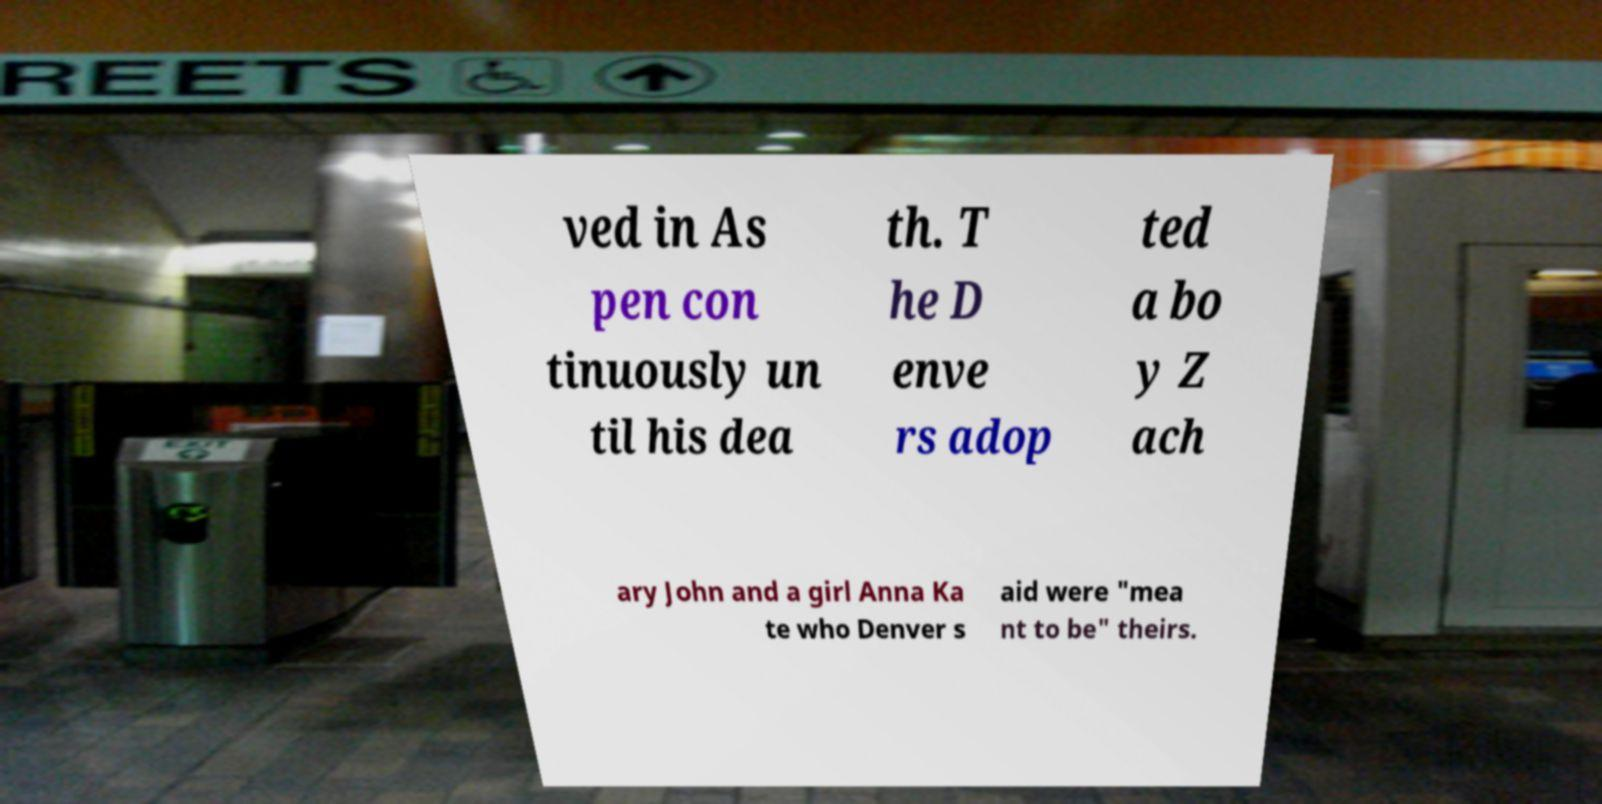Could you assist in decoding the text presented in this image and type it out clearly? ved in As pen con tinuously un til his dea th. T he D enve rs adop ted a bo y Z ach ary John and a girl Anna Ka te who Denver s aid were "mea nt to be" theirs. 